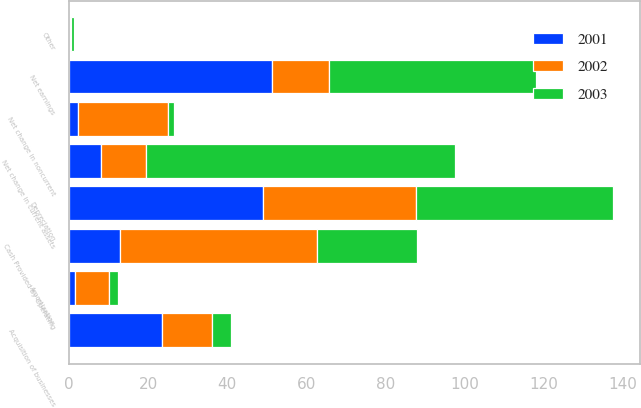<chart> <loc_0><loc_0><loc_500><loc_500><stacked_bar_chart><ecel><fcel>Net earnings<fcel>Depreciation<fcel>Amortization<fcel>Net change in current assets<fcel>Net change in noncurrent<fcel>Other<fcel>Cash Provided by Operating<fcel>Acquisition of businesses<nl><fcel>2003<fcel>52.2<fcel>49.8<fcel>2.3<fcel>78.2<fcel>1.5<fcel>0.7<fcel>25.3<fcel>4.8<nl><fcel>2001<fcel>51.3<fcel>49.1<fcel>1.6<fcel>8.2<fcel>2.3<fcel>0.3<fcel>12.85<fcel>23.4<nl><fcel>2002<fcel>14.5<fcel>38.5<fcel>8.6<fcel>11.2<fcel>22.7<fcel>0.3<fcel>49.8<fcel>12.85<nl></chart> 